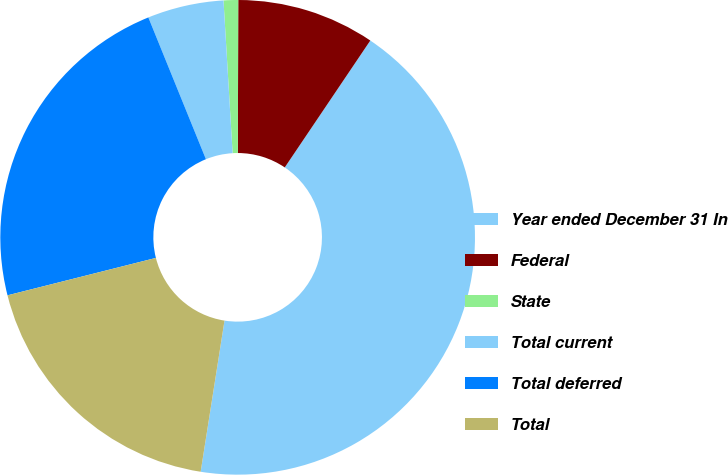<chart> <loc_0><loc_0><loc_500><loc_500><pie_chart><fcel>Year ended December 31 In<fcel>Federal<fcel>State<fcel>Total current<fcel>Total deferred<fcel>Total<nl><fcel>43.05%<fcel>9.4%<fcel>0.99%<fcel>5.19%<fcel>22.79%<fcel>18.58%<nl></chart> 